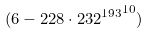<formula> <loc_0><loc_0><loc_500><loc_500>( 6 - 2 2 8 \cdot { 2 3 2 ^ { 1 9 3 } } ^ { 1 0 } )</formula> 